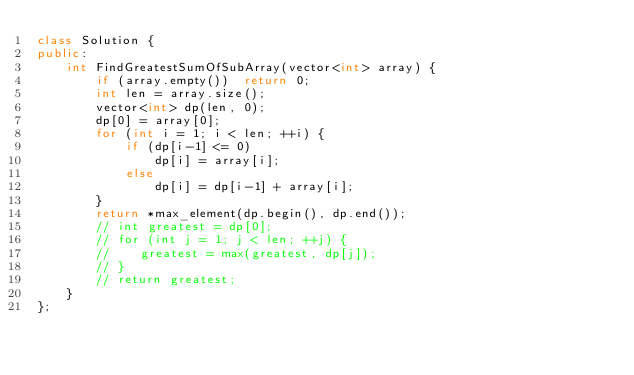Convert code to text. <code><loc_0><loc_0><loc_500><loc_500><_C++_>class Solution {
public:
    int FindGreatestSumOfSubArray(vector<int> array) {
        if (array.empty())  return 0;
        int len = array.size();
        vector<int> dp(len, 0);
        dp[0] = array[0];
        for (int i = 1; i < len; ++i) {
            if (dp[i-1] <= 0)
                dp[i] = array[i];
            else
                dp[i] = dp[i-1] + array[i];
        }
        return *max_element(dp.begin(), dp.end());
        // int greatest = dp[0];
        // for (int j = 1; j < len; ++j) {
        //    greatest = max(greatest, dp[j]);
        // }
        // return greatest;
    }
};</code> 